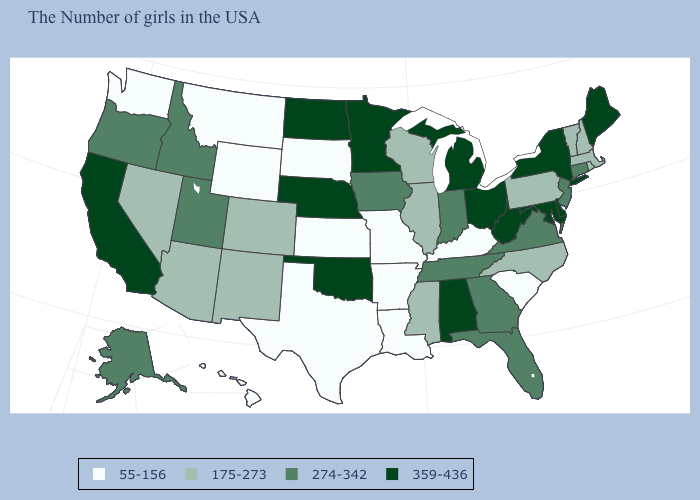Which states have the lowest value in the USA?
Quick response, please. South Carolina, Kentucky, Louisiana, Missouri, Arkansas, Kansas, Texas, South Dakota, Wyoming, Montana, Washington, Hawaii. Among the states that border Nevada , which have the lowest value?
Keep it brief. Arizona. Among the states that border California , does Oregon have the highest value?
Be succinct. Yes. Does Vermont have a lower value than Indiana?
Be succinct. Yes. Name the states that have a value in the range 55-156?
Concise answer only. South Carolina, Kentucky, Louisiana, Missouri, Arkansas, Kansas, Texas, South Dakota, Wyoming, Montana, Washington, Hawaii. Does the map have missing data?
Be succinct. No. What is the value of Oklahoma?
Concise answer only. 359-436. What is the value of New Hampshire?
Answer briefly. 175-273. Which states have the highest value in the USA?
Concise answer only. Maine, New York, Delaware, Maryland, West Virginia, Ohio, Michigan, Alabama, Minnesota, Nebraska, Oklahoma, North Dakota, California. Name the states that have a value in the range 359-436?
Be succinct. Maine, New York, Delaware, Maryland, West Virginia, Ohio, Michigan, Alabama, Minnesota, Nebraska, Oklahoma, North Dakota, California. Name the states that have a value in the range 359-436?
Give a very brief answer. Maine, New York, Delaware, Maryland, West Virginia, Ohio, Michigan, Alabama, Minnesota, Nebraska, Oklahoma, North Dakota, California. What is the value of Wisconsin?
Keep it brief. 175-273. What is the highest value in the West ?
Answer briefly. 359-436. Does the map have missing data?
Quick response, please. No. Which states have the lowest value in the South?
Answer briefly. South Carolina, Kentucky, Louisiana, Arkansas, Texas. 